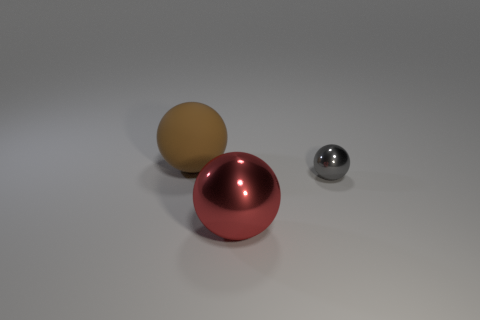Subtract all large balls. How many balls are left? 1 Add 3 tiny metallic balls. How many objects exist? 6 Subtract all gray balls. How many balls are left? 2 Subtract 1 balls. How many balls are left? 2 Subtract all red balls. Subtract all blue cylinders. How many balls are left? 2 Subtract all brown rubber objects. Subtract all small gray metal things. How many objects are left? 1 Add 2 gray things. How many gray things are left? 3 Add 1 large red balls. How many large red balls exist? 2 Subtract 0 blue spheres. How many objects are left? 3 